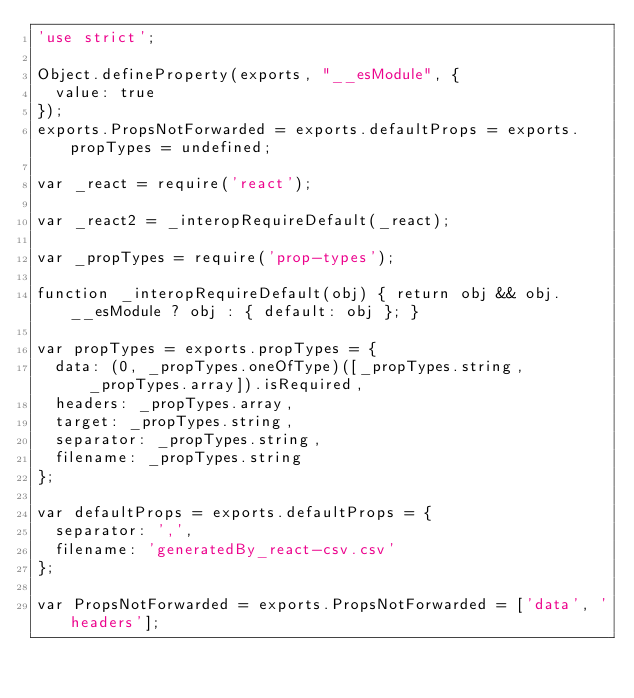Convert code to text. <code><loc_0><loc_0><loc_500><loc_500><_JavaScript_>'use strict';

Object.defineProperty(exports, "__esModule", {
  value: true
});
exports.PropsNotForwarded = exports.defaultProps = exports.propTypes = undefined;

var _react = require('react');

var _react2 = _interopRequireDefault(_react);

var _propTypes = require('prop-types');

function _interopRequireDefault(obj) { return obj && obj.__esModule ? obj : { default: obj }; }

var propTypes = exports.propTypes = {
  data: (0, _propTypes.oneOfType)([_propTypes.string, _propTypes.array]).isRequired,
  headers: _propTypes.array,
  target: _propTypes.string,
  separator: _propTypes.string,
  filename: _propTypes.string
};

var defaultProps = exports.defaultProps = {
  separator: ',',
  filename: 'generatedBy_react-csv.csv'
};

var PropsNotForwarded = exports.PropsNotForwarded = ['data', 'headers'];</code> 